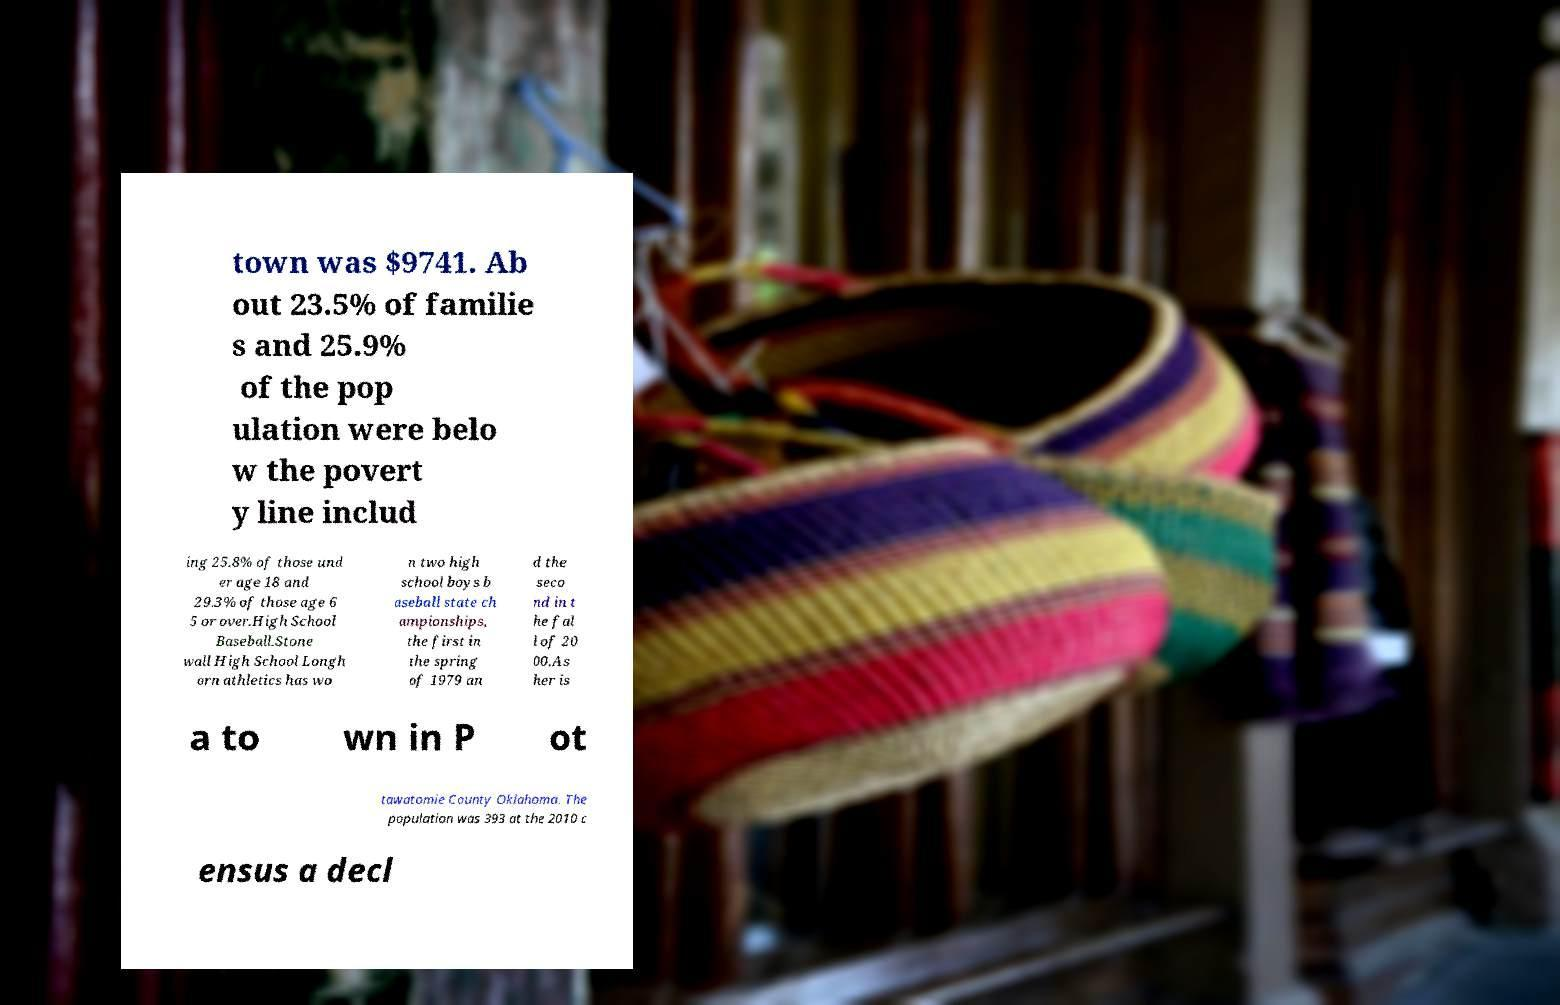Can you accurately transcribe the text from the provided image for me? town was $9741. Ab out 23.5% of familie s and 25.9% of the pop ulation were belo w the povert y line includ ing 25.8% of those und er age 18 and 29.3% of those age 6 5 or over.High School Baseball.Stone wall High School Longh orn athletics has wo n two high school boys b aseball state ch ampionships, the first in the spring of 1979 an d the seco nd in t he fal l of 20 00.As her is a to wn in P ot tawatomie County Oklahoma. The population was 393 at the 2010 c ensus a decl 